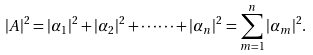Convert formula to latex. <formula><loc_0><loc_0><loc_500><loc_500>| { A } | ^ { 2 } = | \alpha _ { 1 } | ^ { 2 } + | \alpha _ { 2 } | ^ { 2 } + \cdots \cdots + | \alpha _ { n } | ^ { 2 } = \sum _ { m = 1 } ^ { n } | \alpha _ { m } | ^ { 2 } . \\</formula> 